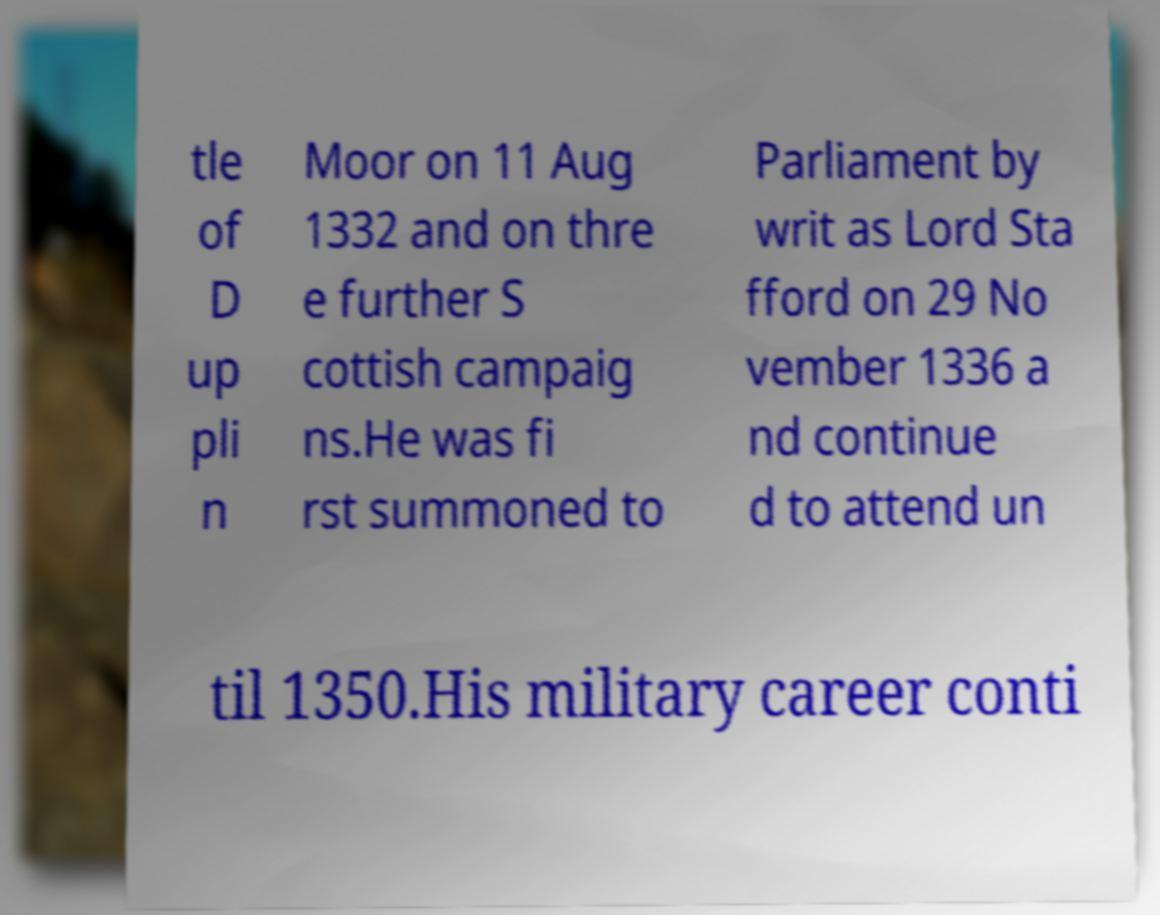Can you read and provide the text displayed in the image?This photo seems to have some interesting text. Can you extract and type it out for me? tle of D up pli n Moor on 11 Aug 1332 and on thre e further S cottish campaig ns.He was fi rst summoned to Parliament by writ as Lord Sta fford on 29 No vember 1336 a nd continue d to attend un til 1350.His military career conti 